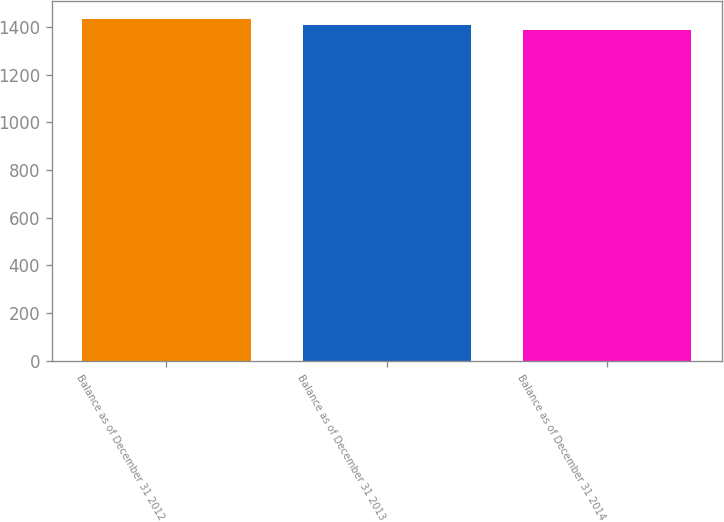Convert chart to OTSL. <chart><loc_0><loc_0><loc_500><loc_500><bar_chart><fcel>Balance as of December 31 2012<fcel>Balance as of December 31 2013<fcel>Balance as of December 31 2014<nl><fcel>1435<fcel>1409<fcel>1387<nl></chart> 